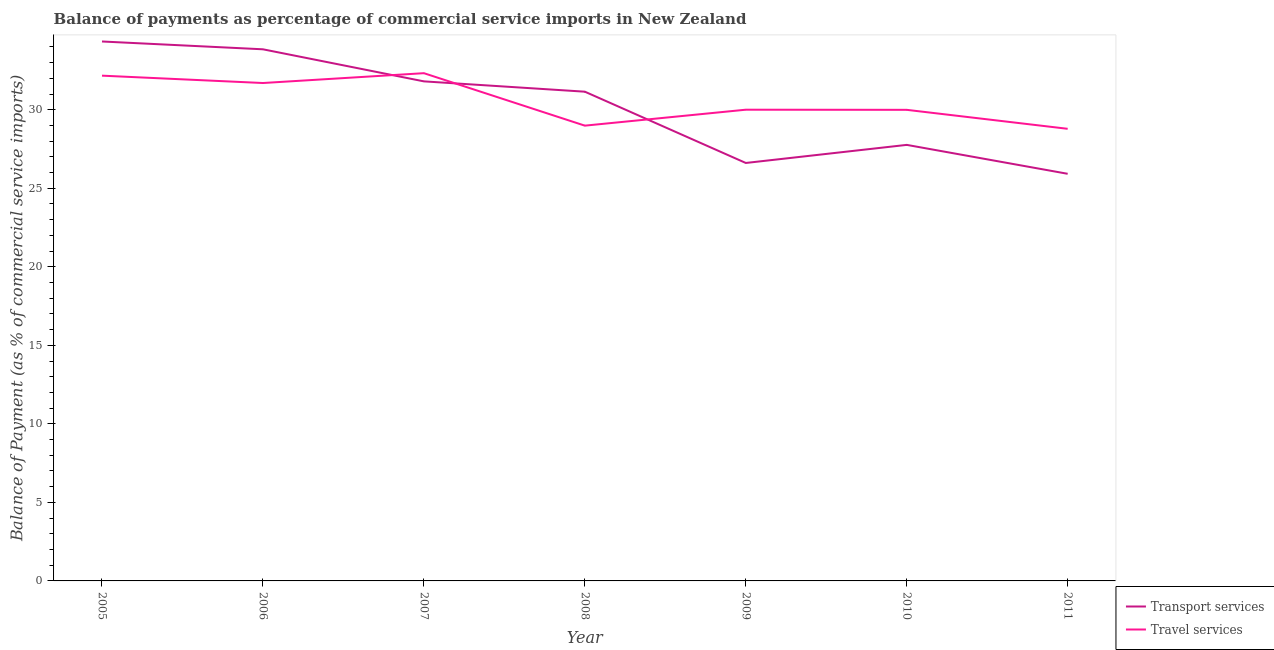What is the balance of payments of travel services in 2005?
Your response must be concise. 32.17. Across all years, what is the maximum balance of payments of travel services?
Your answer should be compact. 32.33. Across all years, what is the minimum balance of payments of transport services?
Make the answer very short. 25.92. In which year was the balance of payments of transport services maximum?
Your response must be concise. 2005. In which year was the balance of payments of transport services minimum?
Give a very brief answer. 2011. What is the total balance of payments of travel services in the graph?
Your response must be concise. 213.96. What is the difference between the balance of payments of travel services in 2006 and that in 2011?
Your answer should be very brief. 2.91. What is the difference between the balance of payments of transport services in 2010 and the balance of payments of travel services in 2009?
Your answer should be very brief. -2.24. What is the average balance of payments of transport services per year?
Offer a terse response. 30.2. In the year 2005, what is the difference between the balance of payments of transport services and balance of payments of travel services?
Provide a short and direct response. 2.17. What is the ratio of the balance of payments of transport services in 2006 to that in 2009?
Offer a terse response. 1.27. What is the difference between the highest and the second highest balance of payments of transport services?
Your answer should be compact. 0.5. What is the difference between the highest and the lowest balance of payments of travel services?
Offer a terse response. 3.54. Is the balance of payments of travel services strictly less than the balance of payments of transport services over the years?
Your answer should be compact. No. How many years are there in the graph?
Your answer should be very brief. 7. What is the difference between two consecutive major ticks on the Y-axis?
Your answer should be very brief. 5. Does the graph contain any zero values?
Make the answer very short. No. Does the graph contain grids?
Offer a terse response. No. Where does the legend appear in the graph?
Offer a terse response. Bottom right. What is the title of the graph?
Your answer should be very brief. Balance of payments as percentage of commercial service imports in New Zealand. Does "Underweight" appear as one of the legend labels in the graph?
Keep it short and to the point. No. What is the label or title of the X-axis?
Provide a succinct answer. Year. What is the label or title of the Y-axis?
Provide a succinct answer. Balance of Payment (as % of commercial service imports). What is the Balance of Payment (as % of commercial service imports) of Transport services in 2005?
Give a very brief answer. 34.34. What is the Balance of Payment (as % of commercial service imports) of Travel services in 2005?
Your response must be concise. 32.17. What is the Balance of Payment (as % of commercial service imports) of Transport services in 2006?
Give a very brief answer. 33.85. What is the Balance of Payment (as % of commercial service imports) in Travel services in 2006?
Your answer should be compact. 31.7. What is the Balance of Payment (as % of commercial service imports) in Transport services in 2007?
Keep it short and to the point. 31.8. What is the Balance of Payment (as % of commercial service imports) in Travel services in 2007?
Your answer should be very brief. 32.33. What is the Balance of Payment (as % of commercial service imports) in Transport services in 2008?
Your answer should be compact. 31.15. What is the Balance of Payment (as % of commercial service imports) in Travel services in 2008?
Offer a very short reply. 28.99. What is the Balance of Payment (as % of commercial service imports) of Transport services in 2009?
Ensure brevity in your answer.  26.61. What is the Balance of Payment (as % of commercial service imports) of Travel services in 2009?
Keep it short and to the point. 30. What is the Balance of Payment (as % of commercial service imports) in Transport services in 2010?
Keep it short and to the point. 27.76. What is the Balance of Payment (as % of commercial service imports) in Travel services in 2010?
Give a very brief answer. 29.99. What is the Balance of Payment (as % of commercial service imports) of Transport services in 2011?
Give a very brief answer. 25.92. What is the Balance of Payment (as % of commercial service imports) of Travel services in 2011?
Your response must be concise. 28.78. Across all years, what is the maximum Balance of Payment (as % of commercial service imports) in Transport services?
Give a very brief answer. 34.34. Across all years, what is the maximum Balance of Payment (as % of commercial service imports) in Travel services?
Offer a very short reply. 32.33. Across all years, what is the minimum Balance of Payment (as % of commercial service imports) in Transport services?
Keep it short and to the point. 25.92. Across all years, what is the minimum Balance of Payment (as % of commercial service imports) in Travel services?
Offer a terse response. 28.78. What is the total Balance of Payment (as % of commercial service imports) in Transport services in the graph?
Make the answer very short. 211.43. What is the total Balance of Payment (as % of commercial service imports) in Travel services in the graph?
Offer a terse response. 213.96. What is the difference between the Balance of Payment (as % of commercial service imports) in Transport services in 2005 and that in 2006?
Your answer should be compact. 0.5. What is the difference between the Balance of Payment (as % of commercial service imports) of Travel services in 2005 and that in 2006?
Keep it short and to the point. 0.47. What is the difference between the Balance of Payment (as % of commercial service imports) of Transport services in 2005 and that in 2007?
Provide a short and direct response. 2.54. What is the difference between the Balance of Payment (as % of commercial service imports) in Travel services in 2005 and that in 2007?
Offer a terse response. -0.16. What is the difference between the Balance of Payment (as % of commercial service imports) of Transport services in 2005 and that in 2008?
Provide a short and direct response. 3.2. What is the difference between the Balance of Payment (as % of commercial service imports) in Travel services in 2005 and that in 2008?
Keep it short and to the point. 3.18. What is the difference between the Balance of Payment (as % of commercial service imports) in Transport services in 2005 and that in 2009?
Offer a very short reply. 7.73. What is the difference between the Balance of Payment (as % of commercial service imports) in Travel services in 2005 and that in 2009?
Your answer should be very brief. 2.17. What is the difference between the Balance of Payment (as % of commercial service imports) of Transport services in 2005 and that in 2010?
Your answer should be compact. 6.58. What is the difference between the Balance of Payment (as % of commercial service imports) of Travel services in 2005 and that in 2010?
Offer a very short reply. 2.18. What is the difference between the Balance of Payment (as % of commercial service imports) in Transport services in 2005 and that in 2011?
Make the answer very short. 8.42. What is the difference between the Balance of Payment (as % of commercial service imports) in Travel services in 2005 and that in 2011?
Provide a short and direct response. 3.38. What is the difference between the Balance of Payment (as % of commercial service imports) of Transport services in 2006 and that in 2007?
Your response must be concise. 2.04. What is the difference between the Balance of Payment (as % of commercial service imports) of Travel services in 2006 and that in 2007?
Make the answer very short. -0.63. What is the difference between the Balance of Payment (as % of commercial service imports) in Transport services in 2006 and that in 2008?
Your response must be concise. 2.7. What is the difference between the Balance of Payment (as % of commercial service imports) in Travel services in 2006 and that in 2008?
Provide a short and direct response. 2.71. What is the difference between the Balance of Payment (as % of commercial service imports) of Transport services in 2006 and that in 2009?
Your answer should be very brief. 7.24. What is the difference between the Balance of Payment (as % of commercial service imports) in Travel services in 2006 and that in 2009?
Your response must be concise. 1.7. What is the difference between the Balance of Payment (as % of commercial service imports) in Transport services in 2006 and that in 2010?
Your answer should be compact. 6.09. What is the difference between the Balance of Payment (as % of commercial service imports) of Travel services in 2006 and that in 2010?
Make the answer very short. 1.71. What is the difference between the Balance of Payment (as % of commercial service imports) of Transport services in 2006 and that in 2011?
Your answer should be very brief. 7.93. What is the difference between the Balance of Payment (as % of commercial service imports) in Travel services in 2006 and that in 2011?
Give a very brief answer. 2.92. What is the difference between the Balance of Payment (as % of commercial service imports) in Transport services in 2007 and that in 2008?
Give a very brief answer. 0.66. What is the difference between the Balance of Payment (as % of commercial service imports) of Travel services in 2007 and that in 2008?
Offer a terse response. 3.34. What is the difference between the Balance of Payment (as % of commercial service imports) of Transport services in 2007 and that in 2009?
Your answer should be very brief. 5.2. What is the difference between the Balance of Payment (as % of commercial service imports) in Travel services in 2007 and that in 2009?
Give a very brief answer. 2.33. What is the difference between the Balance of Payment (as % of commercial service imports) in Transport services in 2007 and that in 2010?
Offer a very short reply. 4.04. What is the difference between the Balance of Payment (as % of commercial service imports) of Travel services in 2007 and that in 2010?
Offer a terse response. 2.33. What is the difference between the Balance of Payment (as % of commercial service imports) of Transport services in 2007 and that in 2011?
Give a very brief answer. 5.88. What is the difference between the Balance of Payment (as % of commercial service imports) of Travel services in 2007 and that in 2011?
Offer a very short reply. 3.54. What is the difference between the Balance of Payment (as % of commercial service imports) in Transport services in 2008 and that in 2009?
Offer a terse response. 4.54. What is the difference between the Balance of Payment (as % of commercial service imports) of Travel services in 2008 and that in 2009?
Ensure brevity in your answer.  -1.01. What is the difference between the Balance of Payment (as % of commercial service imports) of Transport services in 2008 and that in 2010?
Offer a terse response. 3.39. What is the difference between the Balance of Payment (as % of commercial service imports) of Travel services in 2008 and that in 2010?
Provide a short and direct response. -1.01. What is the difference between the Balance of Payment (as % of commercial service imports) in Transport services in 2008 and that in 2011?
Your answer should be compact. 5.23. What is the difference between the Balance of Payment (as % of commercial service imports) in Travel services in 2008 and that in 2011?
Your answer should be compact. 0.2. What is the difference between the Balance of Payment (as % of commercial service imports) of Transport services in 2009 and that in 2010?
Give a very brief answer. -1.15. What is the difference between the Balance of Payment (as % of commercial service imports) in Travel services in 2009 and that in 2010?
Provide a succinct answer. 0.01. What is the difference between the Balance of Payment (as % of commercial service imports) in Transport services in 2009 and that in 2011?
Keep it short and to the point. 0.69. What is the difference between the Balance of Payment (as % of commercial service imports) of Travel services in 2009 and that in 2011?
Provide a succinct answer. 1.22. What is the difference between the Balance of Payment (as % of commercial service imports) in Transport services in 2010 and that in 2011?
Your answer should be compact. 1.84. What is the difference between the Balance of Payment (as % of commercial service imports) of Travel services in 2010 and that in 2011?
Your answer should be compact. 1.21. What is the difference between the Balance of Payment (as % of commercial service imports) of Transport services in 2005 and the Balance of Payment (as % of commercial service imports) of Travel services in 2006?
Give a very brief answer. 2.64. What is the difference between the Balance of Payment (as % of commercial service imports) of Transport services in 2005 and the Balance of Payment (as % of commercial service imports) of Travel services in 2007?
Provide a short and direct response. 2.02. What is the difference between the Balance of Payment (as % of commercial service imports) of Transport services in 2005 and the Balance of Payment (as % of commercial service imports) of Travel services in 2008?
Keep it short and to the point. 5.36. What is the difference between the Balance of Payment (as % of commercial service imports) of Transport services in 2005 and the Balance of Payment (as % of commercial service imports) of Travel services in 2009?
Offer a very short reply. 4.34. What is the difference between the Balance of Payment (as % of commercial service imports) of Transport services in 2005 and the Balance of Payment (as % of commercial service imports) of Travel services in 2010?
Offer a very short reply. 4.35. What is the difference between the Balance of Payment (as % of commercial service imports) of Transport services in 2005 and the Balance of Payment (as % of commercial service imports) of Travel services in 2011?
Your answer should be compact. 5.56. What is the difference between the Balance of Payment (as % of commercial service imports) of Transport services in 2006 and the Balance of Payment (as % of commercial service imports) of Travel services in 2007?
Give a very brief answer. 1.52. What is the difference between the Balance of Payment (as % of commercial service imports) of Transport services in 2006 and the Balance of Payment (as % of commercial service imports) of Travel services in 2008?
Your answer should be very brief. 4.86. What is the difference between the Balance of Payment (as % of commercial service imports) of Transport services in 2006 and the Balance of Payment (as % of commercial service imports) of Travel services in 2009?
Provide a short and direct response. 3.85. What is the difference between the Balance of Payment (as % of commercial service imports) in Transport services in 2006 and the Balance of Payment (as % of commercial service imports) in Travel services in 2010?
Your response must be concise. 3.85. What is the difference between the Balance of Payment (as % of commercial service imports) in Transport services in 2006 and the Balance of Payment (as % of commercial service imports) in Travel services in 2011?
Offer a very short reply. 5.06. What is the difference between the Balance of Payment (as % of commercial service imports) of Transport services in 2007 and the Balance of Payment (as % of commercial service imports) of Travel services in 2008?
Offer a very short reply. 2.82. What is the difference between the Balance of Payment (as % of commercial service imports) in Transport services in 2007 and the Balance of Payment (as % of commercial service imports) in Travel services in 2009?
Make the answer very short. 1.8. What is the difference between the Balance of Payment (as % of commercial service imports) of Transport services in 2007 and the Balance of Payment (as % of commercial service imports) of Travel services in 2010?
Ensure brevity in your answer.  1.81. What is the difference between the Balance of Payment (as % of commercial service imports) in Transport services in 2007 and the Balance of Payment (as % of commercial service imports) in Travel services in 2011?
Make the answer very short. 3.02. What is the difference between the Balance of Payment (as % of commercial service imports) in Transport services in 2008 and the Balance of Payment (as % of commercial service imports) in Travel services in 2009?
Make the answer very short. 1.15. What is the difference between the Balance of Payment (as % of commercial service imports) of Transport services in 2008 and the Balance of Payment (as % of commercial service imports) of Travel services in 2010?
Ensure brevity in your answer.  1.16. What is the difference between the Balance of Payment (as % of commercial service imports) in Transport services in 2008 and the Balance of Payment (as % of commercial service imports) in Travel services in 2011?
Provide a short and direct response. 2.36. What is the difference between the Balance of Payment (as % of commercial service imports) of Transport services in 2009 and the Balance of Payment (as % of commercial service imports) of Travel services in 2010?
Provide a short and direct response. -3.38. What is the difference between the Balance of Payment (as % of commercial service imports) of Transport services in 2009 and the Balance of Payment (as % of commercial service imports) of Travel services in 2011?
Offer a very short reply. -2.18. What is the difference between the Balance of Payment (as % of commercial service imports) of Transport services in 2010 and the Balance of Payment (as % of commercial service imports) of Travel services in 2011?
Offer a very short reply. -1.02. What is the average Balance of Payment (as % of commercial service imports) of Transport services per year?
Your answer should be compact. 30.2. What is the average Balance of Payment (as % of commercial service imports) in Travel services per year?
Your response must be concise. 30.57. In the year 2005, what is the difference between the Balance of Payment (as % of commercial service imports) in Transport services and Balance of Payment (as % of commercial service imports) in Travel services?
Give a very brief answer. 2.17. In the year 2006, what is the difference between the Balance of Payment (as % of commercial service imports) of Transport services and Balance of Payment (as % of commercial service imports) of Travel services?
Keep it short and to the point. 2.15. In the year 2007, what is the difference between the Balance of Payment (as % of commercial service imports) in Transport services and Balance of Payment (as % of commercial service imports) in Travel services?
Provide a succinct answer. -0.52. In the year 2008, what is the difference between the Balance of Payment (as % of commercial service imports) of Transport services and Balance of Payment (as % of commercial service imports) of Travel services?
Your answer should be compact. 2.16. In the year 2009, what is the difference between the Balance of Payment (as % of commercial service imports) of Transport services and Balance of Payment (as % of commercial service imports) of Travel services?
Make the answer very short. -3.39. In the year 2010, what is the difference between the Balance of Payment (as % of commercial service imports) of Transport services and Balance of Payment (as % of commercial service imports) of Travel services?
Provide a succinct answer. -2.23. In the year 2011, what is the difference between the Balance of Payment (as % of commercial service imports) of Transport services and Balance of Payment (as % of commercial service imports) of Travel services?
Ensure brevity in your answer.  -2.86. What is the ratio of the Balance of Payment (as % of commercial service imports) of Transport services in 2005 to that in 2006?
Offer a terse response. 1.01. What is the ratio of the Balance of Payment (as % of commercial service imports) of Travel services in 2005 to that in 2006?
Your answer should be very brief. 1.01. What is the ratio of the Balance of Payment (as % of commercial service imports) in Transport services in 2005 to that in 2007?
Provide a short and direct response. 1.08. What is the ratio of the Balance of Payment (as % of commercial service imports) of Travel services in 2005 to that in 2007?
Give a very brief answer. 1. What is the ratio of the Balance of Payment (as % of commercial service imports) in Transport services in 2005 to that in 2008?
Give a very brief answer. 1.1. What is the ratio of the Balance of Payment (as % of commercial service imports) in Travel services in 2005 to that in 2008?
Offer a very short reply. 1.11. What is the ratio of the Balance of Payment (as % of commercial service imports) in Transport services in 2005 to that in 2009?
Offer a very short reply. 1.29. What is the ratio of the Balance of Payment (as % of commercial service imports) in Travel services in 2005 to that in 2009?
Your answer should be very brief. 1.07. What is the ratio of the Balance of Payment (as % of commercial service imports) of Transport services in 2005 to that in 2010?
Offer a terse response. 1.24. What is the ratio of the Balance of Payment (as % of commercial service imports) of Travel services in 2005 to that in 2010?
Keep it short and to the point. 1.07. What is the ratio of the Balance of Payment (as % of commercial service imports) of Transport services in 2005 to that in 2011?
Provide a succinct answer. 1.32. What is the ratio of the Balance of Payment (as % of commercial service imports) of Travel services in 2005 to that in 2011?
Give a very brief answer. 1.12. What is the ratio of the Balance of Payment (as % of commercial service imports) in Transport services in 2006 to that in 2007?
Provide a succinct answer. 1.06. What is the ratio of the Balance of Payment (as % of commercial service imports) in Travel services in 2006 to that in 2007?
Provide a succinct answer. 0.98. What is the ratio of the Balance of Payment (as % of commercial service imports) in Transport services in 2006 to that in 2008?
Make the answer very short. 1.09. What is the ratio of the Balance of Payment (as % of commercial service imports) of Travel services in 2006 to that in 2008?
Provide a short and direct response. 1.09. What is the ratio of the Balance of Payment (as % of commercial service imports) in Transport services in 2006 to that in 2009?
Provide a short and direct response. 1.27. What is the ratio of the Balance of Payment (as % of commercial service imports) of Travel services in 2006 to that in 2009?
Make the answer very short. 1.06. What is the ratio of the Balance of Payment (as % of commercial service imports) of Transport services in 2006 to that in 2010?
Keep it short and to the point. 1.22. What is the ratio of the Balance of Payment (as % of commercial service imports) of Travel services in 2006 to that in 2010?
Offer a terse response. 1.06. What is the ratio of the Balance of Payment (as % of commercial service imports) in Transport services in 2006 to that in 2011?
Offer a very short reply. 1.31. What is the ratio of the Balance of Payment (as % of commercial service imports) in Travel services in 2006 to that in 2011?
Keep it short and to the point. 1.1. What is the ratio of the Balance of Payment (as % of commercial service imports) in Transport services in 2007 to that in 2008?
Ensure brevity in your answer.  1.02. What is the ratio of the Balance of Payment (as % of commercial service imports) in Travel services in 2007 to that in 2008?
Your answer should be very brief. 1.12. What is the ratio of the Balance of Payment (as % of commercial service imports) in Transport services in 2007 to that in 2009?
Offer a very short reply. 1.2. What is the ratio of the Balance of Payment (as % of commercial service imports) in Travel services in 2007 to that in 2009?
Make the answer very short. 1.08. What is the ratio of the Balance of Payment (as % of commercial service imports) in Transport services in 2007 to that in 2010?
Provide a short and direct response. 1.15. What is the ratio of the Balance of Payment (as % of commercial service imports) of Travel services in 2007 to that in 2010?
Make the answer very short. 1.08. What is the ratio of the Balance of Payment (as % of commercial service imports) in Transport services in 2007 to that in 2011?
Your response must be concise. 1.23. What is the ratio of the Balance of Payment (as % of commercial service imports) of Travel services in 2007 to that in 2011?
Make the answer very short. 1.12. What is the ratio of the Balance of Payment (as % of commercial service imports) of Transport services in 2008 to that in 2009?
Keep it short and to the point. 1.17. What is the ratio of the Balance of Payment (as % of commercial service imports) in Travel services in 2008 to that in 2009?
Your response must be concise. 0.97. What is the ratio of the Balance of Payment (as % of commercial service imports) in Transport services in 2008 to that in 2010?
Your answer should be very brief. 1.12. What is the ratio of the Balance of Payment (as % of commercial service imports) in Travel services in 2008 to that in 2010?
Offer a very short reply. 0.97. What is the ratio of the Balance of Payment (as % of commercial service imports) of Transport services in 2008 to that in 2011?
Make the answer very short. 1.2. What is the ratio of the Balance of Payment (as % of commercial service imports) in Travel services in 2008 to that in 2011?
Offer a terse response. 1.01. What is the ratio of the Balance of Payment (as % of commercial service imports) of Transport services in 2009 to that in 2010?
Provide a succinct answer. 0.96. What is the ratio of the Balance of Payment (as % of commercial service imports) in Transport services in 2009 to that in 2011?
Give a very brief answer. 1.03. What is the ratio of the Balance of Payment (as % of commercial service imports) of Travel services in 2009 to that in 2011?
Offer a very short reply. 1.04. What is the ratio of the Balance of Payment (as % of commercial service imports) in Transport services in 2010 to that in 2011?
Ensure brevity in your answer.  1.07. What is the ratio of the Balance of Payment (as % of commercial service imports) of Travel services in 2010 to that in 2011?
Offer a terse response. 1.04. What is the difference between the highest and the second highest Balance of Payment (as % of commercial service imports) of Transport services?
Keep it short and to the point. 0.5. What is the difference between the highest and the second highest Balance of Payment (as % of commercial service imports) of Travel services?
Offer a very short reply. 0.16. What is the difference between the highest and the lowest Balance of Payment (as % of commercial service imports) of Transport services?
Make the answer very short. 8.42. What is the difference between the highest and the lowest Balance of Payment (as % of commercial service imports) in Travel services?
Your answer should be very brief. 3.54. 